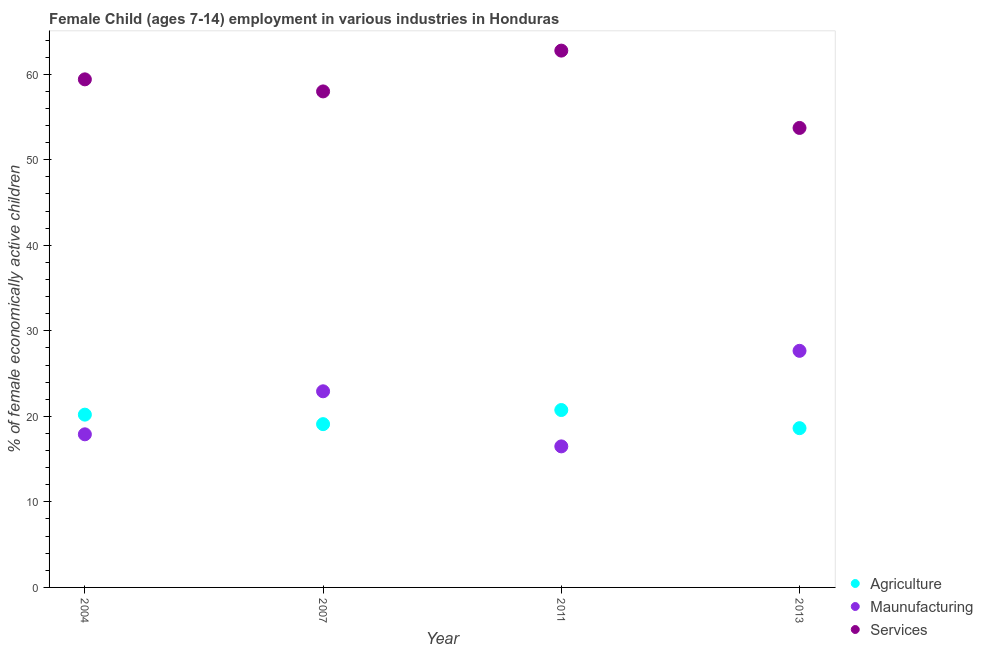Is the number of dotlines equal to the number of legend labels?
Offer a terse response. Yes. What is the percentage of economically active children in manufacturing in 2013?
Provide a succinct answer. 27.66. Across all years, what is the maximum percentage of economically active children in manufacturing?
Your answer should be very brief. 27.66. Across all years, what is the minimum percentage of economically active children in manufacturing?
Offer a terse response. 16.49. In which year was the percentage of economically active children in manufacturing minimum?
Make the answer very short. 2011. What is the total percentage of economically active children in manufacturing in the graph?
Offer a very short reply. 84.98. What is the difference between the percentage of economically active children in agriculture in 2007 and that in 2013?
Your answer should be compact. 0.47. What is the difference between the percentage of economically active children in agriculture in 2011 and the percentage of economically active children in services in 2004?
Keep it short and to the point. -38.66. What is the average percentage of economically active children in services per year?
Offer a very short reply. 58.47. In the year 2004, what is the difference between the percentage of economically active children in agriculture and percentage of economically active children in manufacturing?
Ensure brevity in your answer.  2.3. In how many years, is the percentage of economically active children in agriculture greater than 40 %?
Offer a very short reply. 0. What is the ratio of the percentage of economically active children in services in 2004 to that in 2013?
Your answer should be very brief. 1.11. What is the difference between the highest and the second highest percentage of economically active children in manufacturing?
Offer a terse response. 4.73. What is the difference between the highest and the lowest percentage of economically active children in manufacturing?
Your answer should be compact. 11.17. Is the sum of the percentage of economically active children in manufacturing in 2004 and 2007 greater than the maximum percentage of economically active children in agriculture across all years?
Your answer should be very brief. Yes. Is it the case that in every year, the sum of the percentage of economically active children in agriculture and percentage of economically active children in manufacturing is greater than the percentage of economically active children in services?
Provide a succinct answer. No. Is the percentage of economically active children in manufacturing strictly greater than the percentage of economically active children in agriculture over the years?
Give a very brief answer. No. What is the difference between two consecutive major ticks on the Y-axis?
Ensure brevity in your answer.  10. Are the values on the major ticks of Y-axis written in scientific E-notation?
Provide a short and direct response. No. Where does the legend appear in the graph?
Ensure brevity in your answer.  Bottom right. How are the legend labels stacked?
Offer a terse response. Vertical. What is the title of the graph?
Make the answer very short. Female Child (ages 7-14) employment in various industries in Honduras. Does "Taxes" appear as one of the legend labels in the graph?
Ensure brevity in your answer.  No. What is the label or title of the Y-axis?
Your answer should be very brief. % of female economically active children. What is the % of female economically active children in Agriculture in 2004?
Keep it short and to the point. 20.2. What is the % of female economically active children of Maunufacturing in 2004?
Make the answer very short. 17.9. What is the % of female economically active children of Services in 2004?
Your answer should be compact. 59.4. What is the % of female economically active children of Agriculture in 2007?
Provide a short and direct response. 19.09. What is the % of female economically active children in Maunufacturing in 2007?
Ensure brevity in your answer.  22.93. What is the % of female economically active children in Services in 2007?
Offer a terse response. 57.99. What is the % of female economically active children in Agriculture in 2011?
Provide a succinct answer. 20.74. What is the % of female economically active children in Maunufacturing in 2011?
Provide a succinct answer. 16.49. What is the % of female economically active children in Services in 2011?
Your answer should be very brief. 62.76. What is the % of female economically active children in Agriculture in 2013?
Your response must be concise. 18.62. What is the % of female economically active children in Maunufacturing in 2013?
Make the answer very short. 27.66. What is the % of female economically active children of Services in 2013?
Your answer should be very brief. 53.72. Across all years, what is the maximum % of female economically active children in Agriculture?
Your answer should be compact. 20.74. Across all years, what is the maximum % of female economically active children of Maunufacturing?
Give a very brief answer. 27.66. Across all years, what is the maximum % of female economically active children of Services?
Your response must be concise. 62.76. Across all years, what is the minimum % of female economically active children in Agriculture?
Keep it short and to the point. 18.62. Across all years, what is the minimum % of female economically active children of Maunufacturing?
Keep it short and to the point. 16.49. Across all years, what is the minimum % of female economically active children of Services?
Ensure brevity in your answer.  53.72. What is the total % of female economically active children in Agriculture in the graph?
Your answer should be compact. 78.65. What is the total % of female economically active children in Maunufacturing in the graph?
Keep it short and to the point. 84.98. What is the total % of female economically active children in Services in the graph?
Your response must be concise. 233.87. What is the difference between the % of female economically active children of Agriculture in 2004 and that in 2007?
Keep it short and to the point. 1.11. What is the difference between the % of female economically active children in Maunufacturing in 2004 and that in 2007?
Ensure brevity in your answer.  -5.03. What is the difference between the % of female economically active children in Services in 2004 and that in 2007?
Your answer should be very brief. 1.41. What is the difference between the % of female economically active children in Agriculture in 2004 and that in 2011?
Provide a short and direct response. -0.54. What is the difference between the % of female economically active children of Maunufacturing in 2004 and that in 2011?
Keep it short and to the point. 1.41. What is the difference between the % of female economically active children of Services in 2004 and that in 2011?
Your answer should be very brief. -3.36. What is the difference between the % of female economically active children of Agriculture in 2004 and that in 2013?
Your answer should be very brief. 1.58. What is the difference between the % of female economically active children of Maunufacturing in 2004 and that in 2013?
Provide a short and direct response. -9.76. What is the difference between the % of female economically active children in Services in 2004 and that in 2013?
Keep it short and to the point. 5.68. What is the difference between the % of female economically active children of Agriculture in 2007 and that in 2011?
Keep it short and to the point. -1.65. What is the difference between the % of female economically active children of Maunufacturing in 2007 and that in 2011?
Give a very brief answer. 6.44. What is the difference between the % of female economically active children of Services in 2007 and that in 2011?
Keep it short and to the point. -4.77. What is the difference between the % of female economically active children in Agriculture in 2007 and that in 2013?
Offer a very short reply. 0.47. What is the difference between the % of female economically active children of Maunufacturing in 2007 and that in 2013?
Your response must be concise. -4.73. What is the difference between the % of female economically active children of Services in 2007 and that in 2013?
Make the answer very short. 4.27. What is the difference between the % of female economically active children in Agriculture in 2011 and that in 2013?
Keep it short and to the point. 2.12. What is the difference between the % of female economically active children in Maunufacturing in 2011 and that in 2013?
Offer a terse response. -11.17. What is the difference between the % of female economically active children of Services in 2011 and that in 2013?
Make the answer very short. 9.04. What is the difference between the % of female economically active children in Agriculture in 2004 and the % of female economically active children in Maunufacturing in 2007?
Provide a succinct answer. -2.73. What is the difference between the % of female economically active children of Agriculture in 2004 and the % of female economically active children of Services in 2007?
Your response must be concise. -37.79. What is the difference between the % of female economically active children in Maunufacturing in 2004 and the % of female economically active children in Services in 2007?
Keep it short and to the point. -40.09. What is the difference between the % of female economically active children in Agriculture in 2004 and the % of female economically active children in Maunufacturing in 2011?
Your answer should be very brief. 3.71. What is the difference between the % of female economically active children in Agriculture in 2004 and the % of female economically active children in Services in 2011?
Ensure brevity in your answer.  -42.56. What is the difference between the % of female economically active children in Maunufacturing in 2004 and the % of female economically active children in Services in 2011?
Your response must be concise. -44.86. What is the difference between the % of female economically active children of Agriculture in 2004 and the % of female economically active children of Maunufacturing in 2013?
Make the answer very short. -7.46. What is the difference between the % of female economically active children in Agriculture in 2004 and the % of female economically active children in Services in 2013?
Keep it short and to the point. -33.52. What is the difference between the % of female economically active children of Maunufacturing in 2004 and the % of female economically active children of Services in 2013?
Make the answer very short. -35.82. What is the difference between the % of female economically active children in Agriculture in 2007 and the % of female economically active children in Services in 2011?
Provide a succinct answer. -43.67. What is the difference between the % of female economically active children in Maunufacturing in 2007 and the % of female economically active children in Services in 2011?
Your answer should be very brief. -39.83. What is the difference between the % of female economically active children of Agriculture in 2007 and the % of female economically active children of Maunufacturing in 2013?
Keep it short and to the point. -8.57. What is the difference between the % of female economically active children in Agriculture in 2007 and the % of female economically active children in Services in 2013?
Offer a terse response. -34.63. What is the difference between the % of female economically active children in Maunufacturing in 2007 and the % of female economically active children in Services in 2013?
Your response must be concise. -30.79. What is the difference between the % of female economically active children of Agriculture in 2011 and the % of female economically active children of Maunufacturing in 2013?
Give a very brief answer. -6.92. What is the difference between the % of female economically active children in Agriculture in 2011 and the % of female economically active children in Services in 2013?
Ensure brevity in your answer.  -32.98. What is the difference between the % of female economically active children of Maunufacturing in 2011 and the % of female economically active children of Services in 2013?
Ensure brevity in your answer.  -37.23. What is the average % of female economically active children in Agriculture per year?
Your response must be concise. 19.66. What is the average % of female economically active children in Maunufacturing per year?
Give a very brief answer. 21.25. What is the average % of female economically active children in Services per year?
Your response must be concise. 58.47. In the year 2004, what is the difference between the % of female economically active children in Agriculture and % of female economically active children in Services?
Provide a succinct answer. -39.2. In the year 2004, what is the difference between the % of female economically active children in Maunufacturing and % of female economically active children in Services?
Your response must be concise. -41.5. In the year 2007, what is the difference between the % of female economically active children of Agriculture and % of female economically active children of Maunufacturing?
Make the answer very short. -3.84. In the year 2007, what is the difference between the % of female economically active children of Agriculture and % of female economically active children of Services?
Your answer should be compact. -38.9. In the year 2007, what is the difference between the % of female economically active children of Maunufacturing and % of female economically active children of Services?
Keep it short and to the point. -35.06. In the year 2011, what is the difference between the % of female economically active children of Agriculture and % of female economically active children of Maunufacturing?
Provide a succinct answer. 4.25. In the year 2011, what is the difference between the % of female economically active children in Agriculture and % of female economically active children in Services?
Your answer should be very brief. -42.02. In the year 2011, what is the difference between the % of female economically active children in Maunufacturing and % of female economically active children in Services?
Keep it short and to the point. -46.27. In the year 2013, what is the difference between the % of female economically active children in Agriculture and % of female economically active children in Maunufacturing?
Your answer should be very brief. -9.04. In the year 2013, what is the difference between the % of female economically active children of Agriculture and % of female economically active children of Services?
Give a very brief answer. -35.1. In the year 2013, what is the difference between the % of female economically active children in Maunufacturing and % of female economically active children in Services?
Your answer should be compact. -26.06. What is the ratio of the % of female economically active children in Agriculture in 2004 to that in 2007?
Offer a very short reply. 1.06. What is the ratio of the % of female economically active children of Maunufacturing in 2004 to that in 2007?
Ensure brevity in your answer.  0.78. What is the ratio of the % of female economically active children of Services in 2004 to that in 2007?
Your response must be concise. 1.02. What is the ratio of the % of female economically active children of Maunufacturing in 2004 to that in 2011?
Offer a terse response. 1.09. What is the ratio of the % of female economically active children of Services in 2004 to that in 2011?
Make the answer very short. 0.95. What is the ratio of the % of female economically active children of Agriculture in 2004 to that in 2013?
Provide a short and direct response. 1.08. What is the ratio of the % of female economically active children in Maunufacturing in 2004 to that in 2013?
Give a very brief answer. 0.65. What is the ratio of the % of female economically active children of Services in 2004 to that in 2013?
Give a very brief answer. 1.11. What is the ratio of the % of female economically active children in Agriculture in 2007 to that in 2011?
Provide a short and direct response. 0.92. What is the ratio of the % of female economically active children in Maunufacturing in 2007 to that in 2011?
Give a very brief answer. 1.39. What is the ratio of the % of female economically active children of Services in 2007 to that in 2011?
Your answer should be compact. 0.92. What is the ratio of the % of female economically active children in Agriculture in 2007 to that in 2013?
Keep it short and to the point. 1.03. What is the ratio of the % of female economically active children in Maunufacturing in 2007 to that in 2013?
Offer a very short reply. 0.83. What is the ratio of the % of female economically active children of Services in 2007 to that in 2013?
Offer a terse response. 1.08. What is the ratio of the % of female economically active children in Agriculture in 2011 to that in 2013?
Make the answer very short. 1.11. What is the ratio of the % of female economically active children in Maunufacturing in 2011 to that in 2013?
Keep it short and to the point. 0.6. What is the ratio of the % of female economically active children of Services in 2011 to that in 2013?
Your answer should be very brief. 1.17. What is the difference between the highest and the second highest % of female economically active children of Agriculture?
Make the answer very short. 0.54. What is the difference between the highest and the second highest % of female economically active children of Maunufacturing?
Your answer should be compact. 4.73. What is the difference between the highest and the second highest % of female economically active children in Services?
Offer a terse response. 3.36. What is the difference between the highest and the lowest % of female economically active children in Agriculture?
Your answer should be compact. 2.12. What is the difference between the highest and the lowest % of female economically active children in Maunufacturing?
Your answer should be very brief. 11.17. What is the difference between the highest and the lowest % of female economically active children in Services?
Provide a short and direct response. 9.04. 